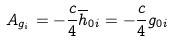Convert formula to latex. <formula><loc_0><loc_0><loc_500><loc_500>A _ { g _ { i } } = - \frac { c } { 4 } \overline { h } _ { 0 i } = - \frac { c } { 4 } g _ { 0 i }</formula> 